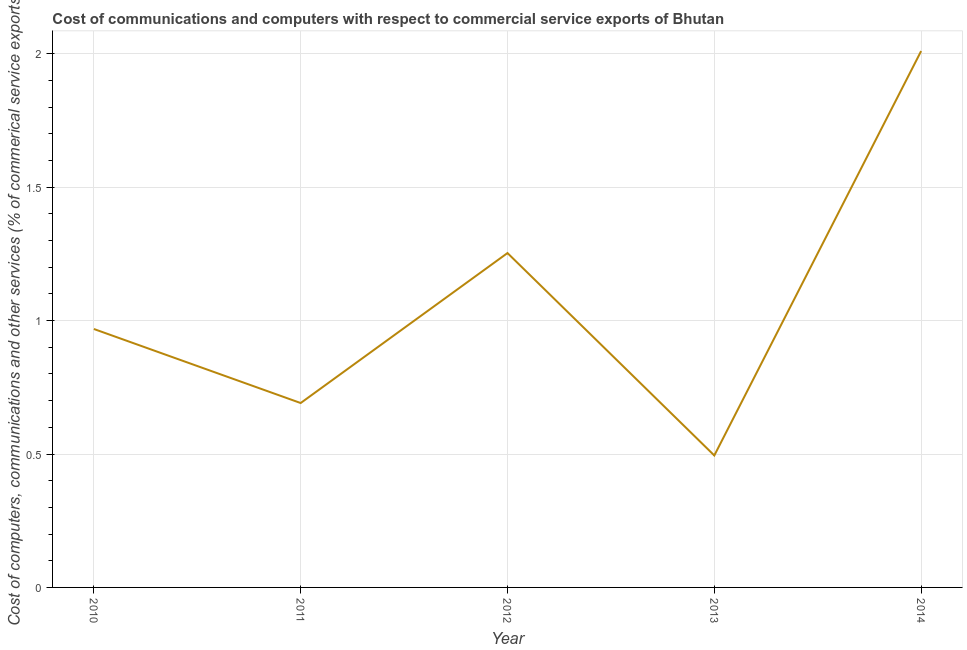What is the cost of communications in 2010?
Provide a short and direct response. 0.97. Across all years, what is the maximum cost of communications?
Your answer should be compact. 2.01. Across all years, what is the minimum cost of communications?
Your answer should be very brief. 0.49. In which year was the cost of communications maximum?
Provide a succinct answer. 2014. What is the sum of the cost of communications?
Provide a short and direct response. 5.42. What is the difference between the  computer and other services in 2013 and 2014?
Provide a succinct answer. -1.52. What is the average  computer and other services per year?
Give a very brief answer. 1.08. What is the median  computer and other services?
Give a very brief answer. 0.97. Do a majority of the years between 2013 and 2014 (inclusive) have cost of communications greater than 1.7 %?
Make the answer very short. No. What is the ratio of the cost of communications in 2010 to that in 2011?
Give a very brief answer. 1.4. What is the difference between the highest and the second highest cost of communications?
Offer a terse response. 0.76. What is the difference between the highest and the lowest cost of communications?
Offer a very short reply. 1.52. Does the cost of communications monotonically increase over the years?
Keep it short and to the point. No. How many lines are there?
Your response must be concise. 1. How many years are there in the graph?
Your response must be concise. 5. What is the difference between two consecutive major ticks on the Y-axis?
Make the answer very short. 0.5. Are the values on the major ticks of Y-axis written in scientific E-notation?
Offer a very short reply. No. What is the title of the graph?
Your response must be concise. Cost of communications and computers with respect to commercial service exports of Bhutan. What is the label or title of the X-axis?
Keep it short and to the point. Year. What is the label or title of the Y-axis?
Your answer should be very brief. Cost of computers, communications and other services (% of commerical service exports). What is the Cost of computers, communications and other services (% of commerical service exports) of 2010?
Keep it short and to the point. 0.97. What is the Cost of computers, communications and other services (% of commerical service exports) of 2011?
Your answer should be very brief. 0.69. What is the Cost of computers, communications and other services (% of commerical service exports) of 2012?
Keep it short and to the point. 1.25. What is the Cost of computers, communications and other services (% of commerical service exports) in 2013?
Provide a short and direct response. 0.49. What is the Cost of computers, communications and other services (% of commerical service exports) of 2014?
Offer a very short reply. 2.01. What is the difference between the Cost of computers, communications and other services (% of commerical service exports) in 2010 and 2011?
Give a very brief answer. 0.28. What is the difference between the Cost of computers, communications and other services (% of commerical service exports) in 2010 and 2012?
Provide a succinct answer. -0.28. What is the difference between the Cost of computers, communications and other services (% of commerical service exports) in 2010 and 2013?
Ensure brevity in your answer.  0.47. What is the difference between the Cost of computers, communications and other services (% of commerical service exports) in 2010 and 2014?
Your answer should be compact. -1.04. What is the difference between the Cost of computers, communications and other services (% of commerical service exports) in 2011 and 2012?
Make the answer very short. -0.56. What is the difference between the Cost of computers, communications and other services (% of commerical service exports) in 2011 and 2013?
Keep it short and to the point. 0.2. What is the difference between the Cost of computers, communications and other services (% of commerical service exports) in 2011 and 2014?
Offer a terse response. -1.32. What is the difference between the Cost of computers, communications and other services (% of commerical service exports) in 2012 and 2013?
Make the answer very short. 0.76. What is the difference between the Cost of computers, communications and other services (% of commerical service exports) in 2012 and 2014?
Ensure brevity in your answer.  -0.76. What is the difference between the Cost of computers, communications and other services (% of commerical service exports) in 2013 and 2014?
Provide a short and direct response. -1.52. What is the ratio of the Cost of computers, communications and other services (% of commerical service exports) in 2010 to that in 2011?
Provide a short and direct response. 1.4. What is the ratio of the Cost of computers, communications and other services (% of commerical service exports) in 2010 to that in 2012?
Keep it short and to the point. 0.77. What is the ratio of the Cost of computers, communications and other services (% of commerical service exports) in 2010 to that in 2013?
Offer a very short reply. 1.96. What is the ratio of the Cost of computers, communications and other services (% of commerical service exports) in 2010 to that in 2014?
Your answer should be compact. 0.48. What is the ratio of the Cost of computers, communications and other services (% of commerical service exports) in 2011 to that in 2012?
Keep it short and to the point. 0.55. What is the ratio of the Cost of computers, communications and other services (% of commerical service exports) in 2011 to that in 2013?
Provide a short and direct response. 1.4. What is the ratio of the Cost of computers, communications and other services (% of commerical service exports) in 2011 to that in 2014?
Give a very brief answer. 0.34. What is the ratio of the Cost of computers, communications and other services (% of commerical service exports) in 2012 to that in 2013?
Your answer should be very brief. 2.53. What is the ratio of the Cost of computers, communications and other services (% of commerical service exports) in 2012 to that in 2014?
Your response must be concise. 0.62. What is the ratio of the Cost of computers, communications and other services (% of commerical service exports) in 2013 to that in 2014?
Your response must be concise. 0.25. 